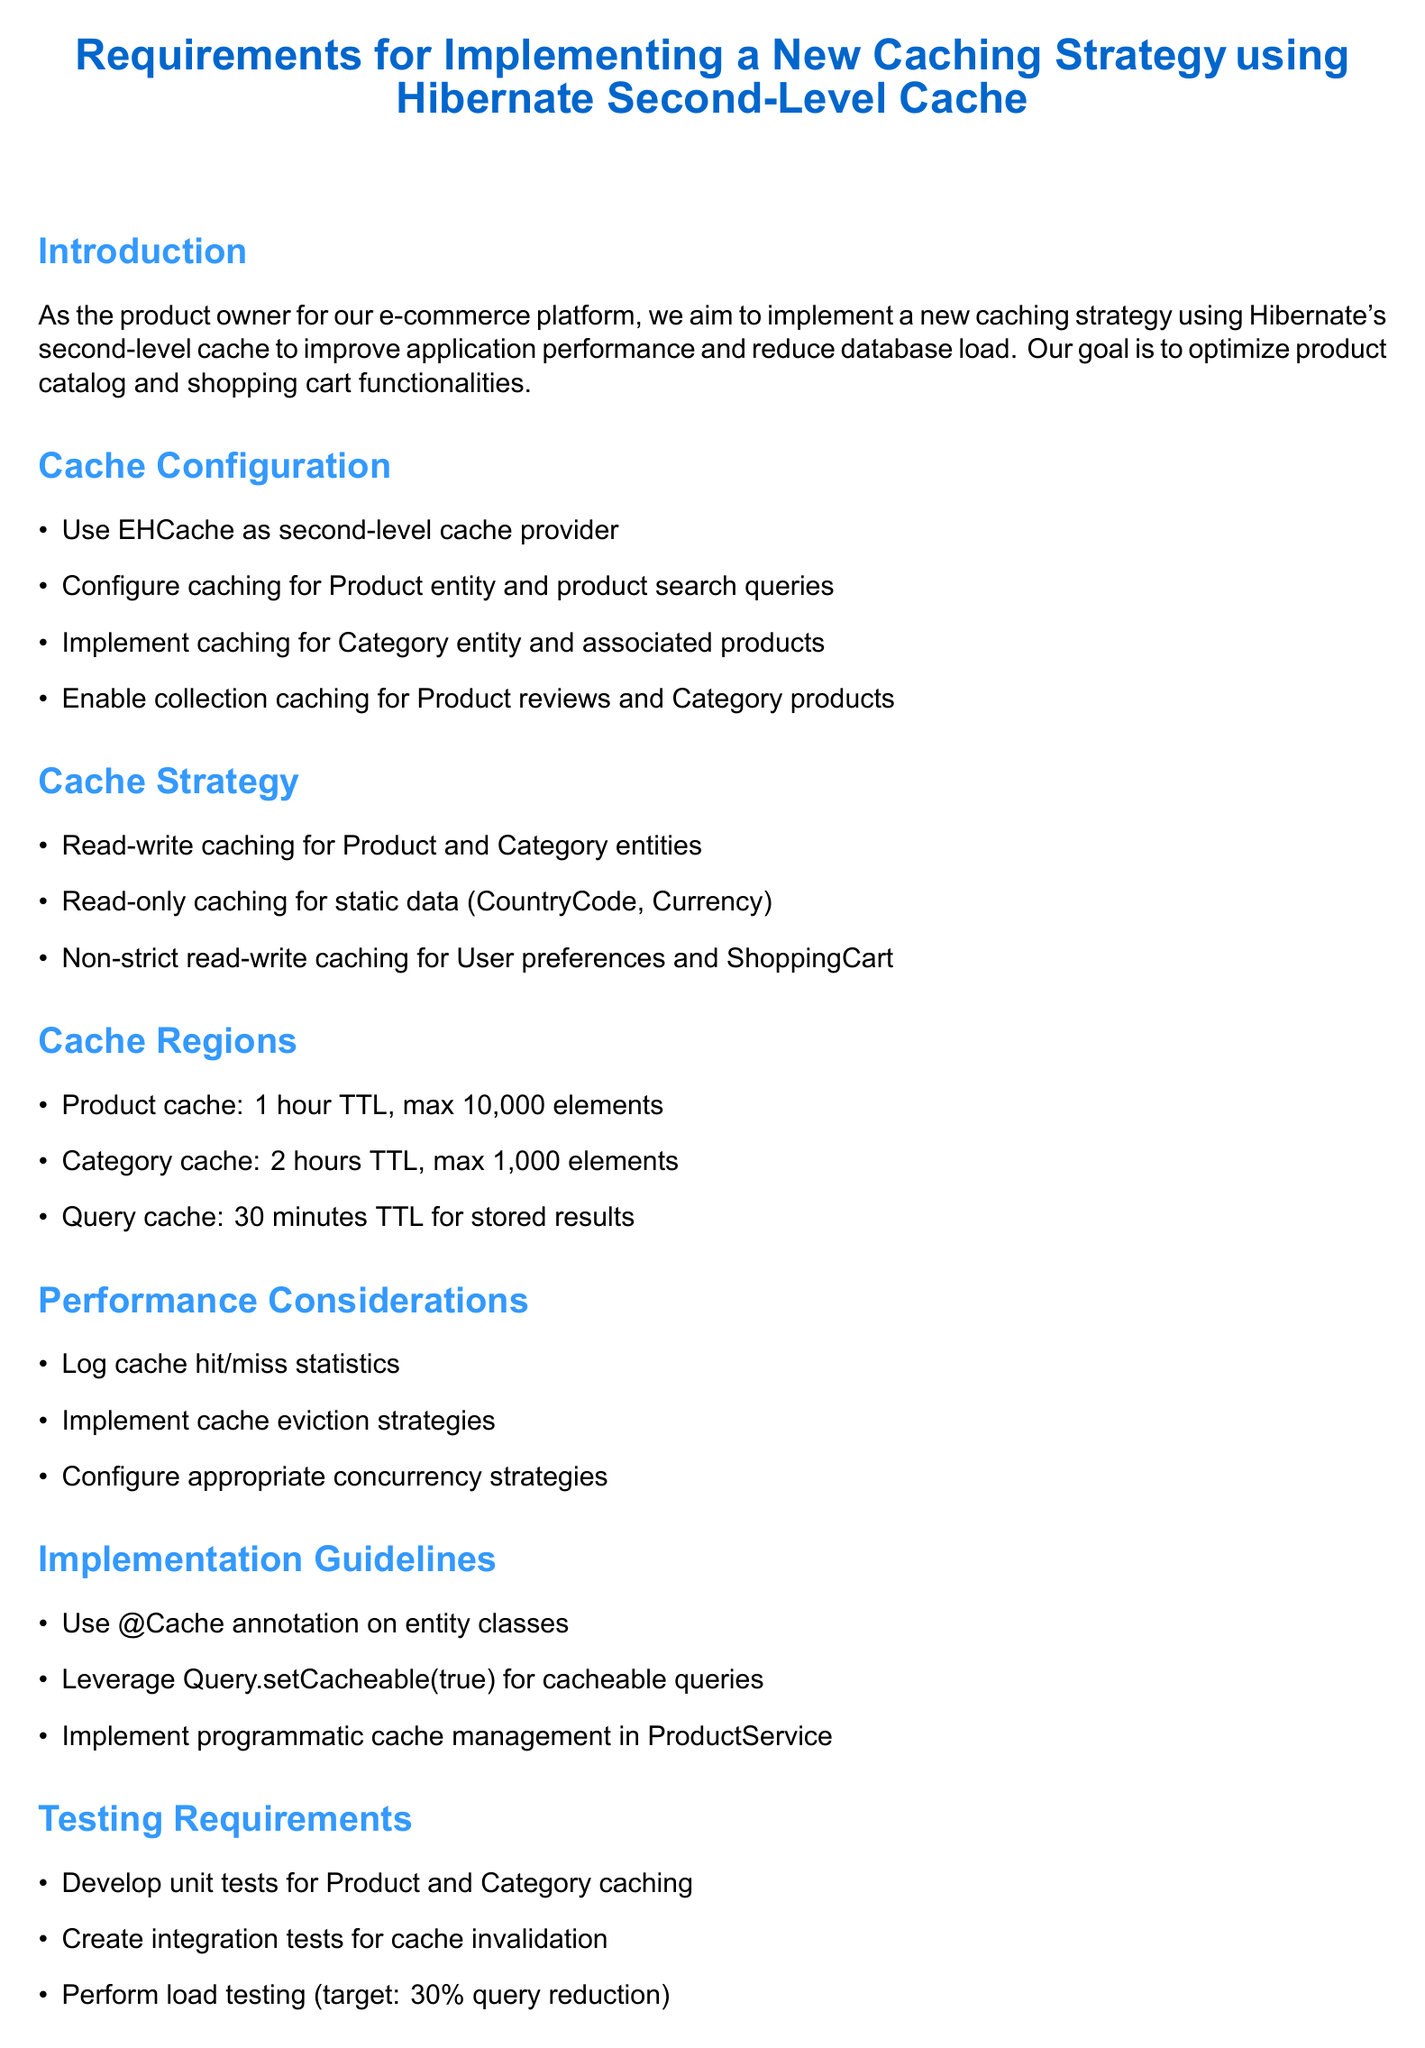What is the cache provider used? The document specifies that EHCache will be used as the second-level cache provider.
Answer: EHCache How long is the TTL for the product cache region? The document states that the product cache region has a time-to-live of 1 hour.
Answer: 1 hour What strategy will be used for Product and Category entities? The memo indicates that a read-write caching strategy will be used for these entities.
Answer: read-write What type of caching is applied to static data entities? The document mentions that read-only caching will be implemented for static data like CountryCode and Currency entities.
Answer: read-only What is the target reduction in database queries for load testing? The document specifies a target of a 30% reduction in database queries for product catalog operations during load testing.
Answer: 30% Which method should be used for cacheable queries? The memo advises leveraging Query.setCacheable(true) for queries that should be cached.
Answer: Query.setCacheable(true) What is one of the performance consideration metrics to be logged? The document notes that cache hit/miss statistics should be logged for monitoring and optimization.
Answer: cache hit/miss statistics What is expected from the development team before implementation? The document states that the development team should provide an implementation plan and timeline before proceeding.
Answer: implementation plan and timeline 